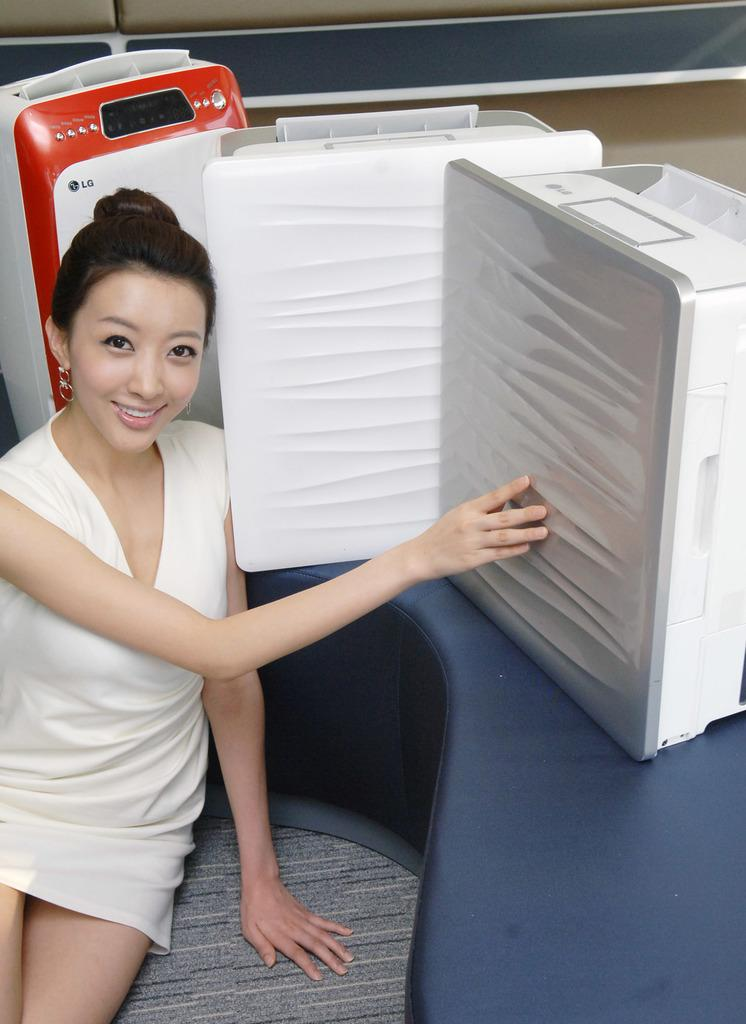What is the lady doing in the image? The lady is sitting in the image. What is present on the table in the image? There are machines on the table in the image. What scent can be detected from the machines in the image? There is no information about the scent of the machines in the image, as the focus is on the lady and the machines themselves. 